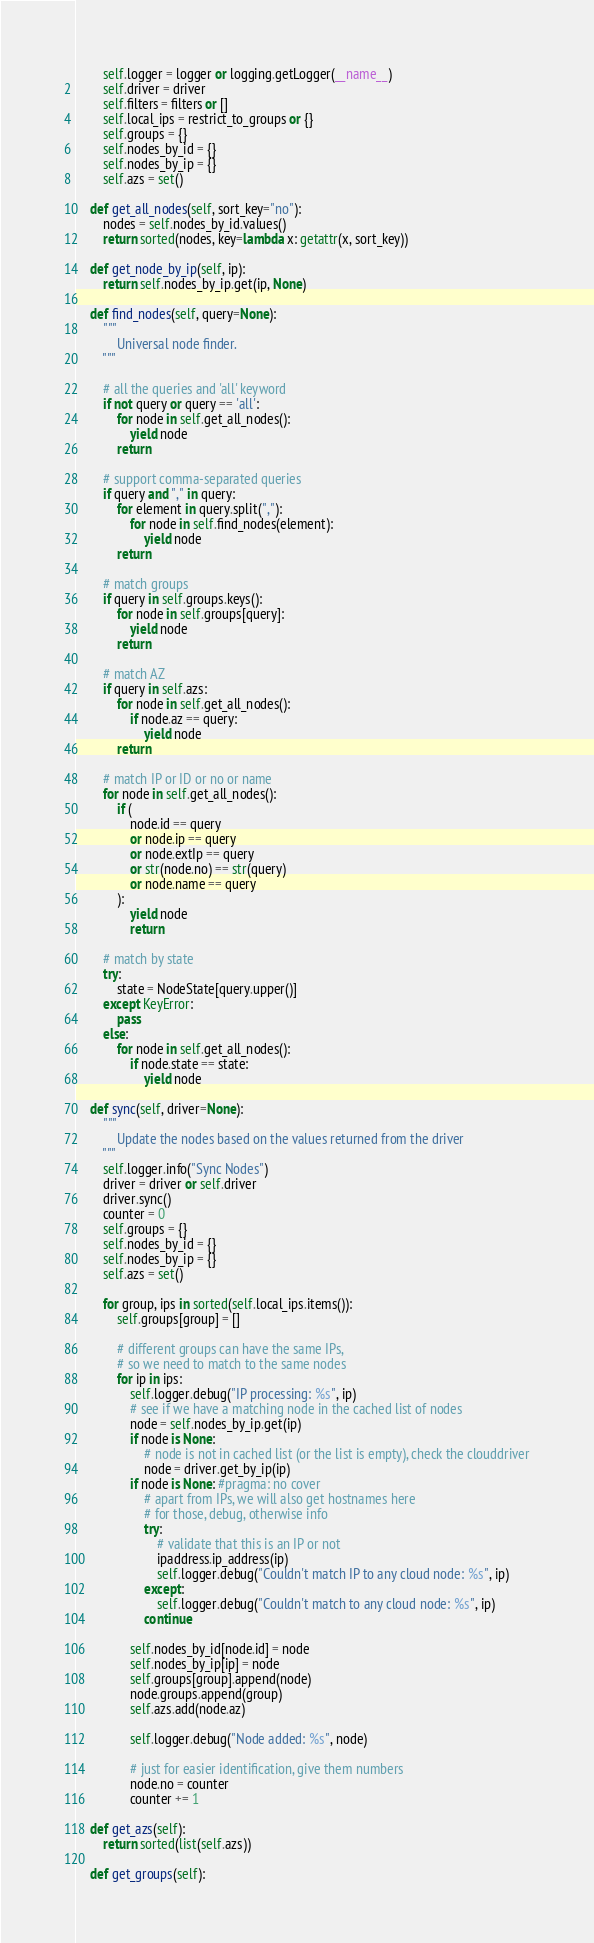Convert code to text. <code><loc_0><loc_0><loc_500><loc_500><_Python_>        self.logger = logger or logging.getLogger(__name__)
        self.driver = driver
        self.filters = filters or []
        self.local_ips = restrict_to_groups or {}
        self.groups = {}
        self.nodes_by_id = {}
        self.nodes_by_ip = {}
        self.azs = set()

    def get_all_nodes(self, sort_key="no"):
        nodes = self.nodes_by_id.values()
        return sorted(nodes, key=lambda x: getattr(x, sort_key))

    def get_node_by_ip(self, ip):
        return self.nodes_by_ip.get(ip, None)

    def find_nodes(self, query=None):
        """
            Universal node finder.
        """

        # all the queries and 'all' keyword
        if not query or query == 'all':
            for node in self.get_all_nodes():
                yield node
            return

        # support comma-separated queries
        if query and "," in query:
            for element in query.split(","):
                for node in self.find_nodes(element):
                    yield node
            return

        # match groups
        if query in self.groups.keys():
            for node in self.groups[query]:
                yield node
            return

        # match AZ
        if query in self.azs:
            for node in self.get_all_nodes():
                if node.az == query:
                    yield node
            return

        # match IP or ID or no or name
        for node in self.get_all_nodes():
            if (
                node.id == query
                or node.ip == query
                or node.extIp == query
                or str(node.no) == str(query)
                or node.name == query
            ):
                yield node
                return

        # match by state
        try:
            state = NodeState[query.upper()]
        except KeyError:
            pass
        else:
            for node in self.get_all_nodes():
                if node.state == state:
                    yield node

    def sync(self, driver=None):
        """
            Update the nodes based on the values returned from the driver
        """
        self.logger.info("Sync Nodes")
        driver = driver or self.driver
        driver.sync()
        counter = 0
        self.groups = {}
        self.nodes_by_id = {}
        self.nodes_by_ip = {}
        self.azs = set()

        for group, ips in sorted(self.local_ips.items()):
            self.groups[group] = []

            # different groups can have the same IPs,
            # so we need to match to the same nodes
            for ip in ips:
                self.logger.debug("IP processing: %s", ip)
                # see if we have a matching node in the cached list of nodes
                node = self.nodes_by_ip.get(ip)
                if node is None:
                    # node is not in cached list (or the list is empty), check the clouddriver
                    node = driver.get_by_ip(ip)
                if node is None: #pragma: no cover
                    # apart from IPs, we will also get hostnames here
                    # for those, debug, otherwise info
                    try:
                        # validate that this is an IP or not
                        ipaddress.ip_address(ip)
                        self.logger.debug("Couldn't match IP to any cloud node: %s", ip)
                    except:
                        self.logger.debug("Couldn't match to any cloud node: %s", ip)
                    continue

                self.nodes_by_id[node.id] = node
                self.nodes_by_ip[ip] = node
                self.groups[group].append(node)
                node.groups.append(group)
                self.azs.add(node.az)

                self.logger.debug("Node added: %s", node)

                # just for easier identification, give them numbers
                node.no = counter
                counter += 1

    def get_azs(self):
        return sorted(list(self.azs))

    def get_groups(self):</code> 